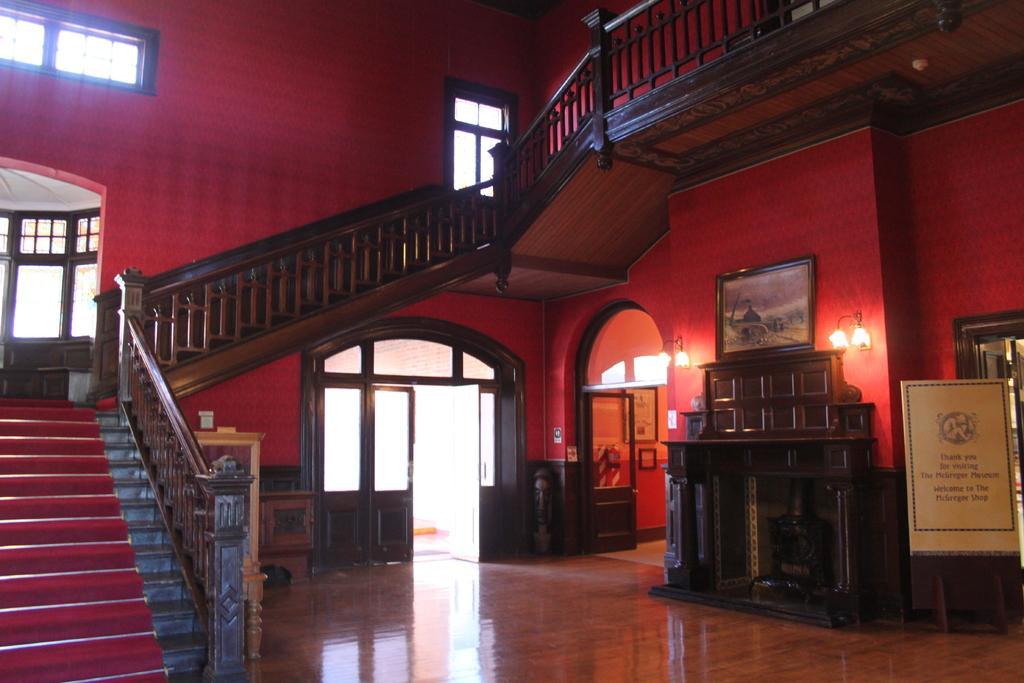Can you describe this image briefly? This picture shows an inner view of a house. We see stairs and a board with some text on it and we see few photo frames on the wall and few lights and we see doors and a window and we see couple photo frames on the wall and a stool on the side. 